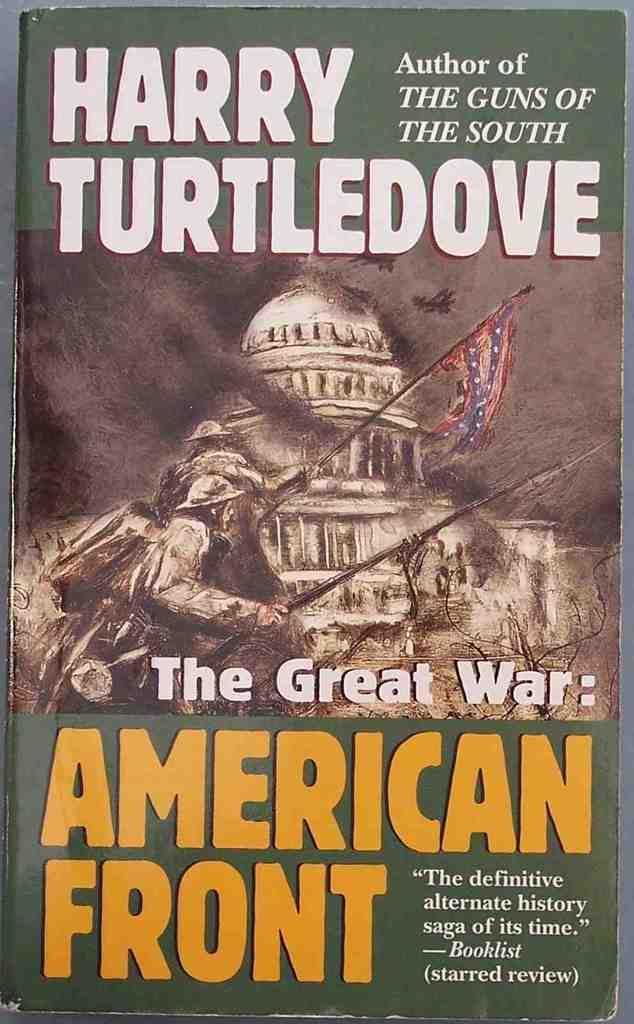<image>
Create a compact narrative representing the image presented. the front of the great war: american front by harry turtledove 